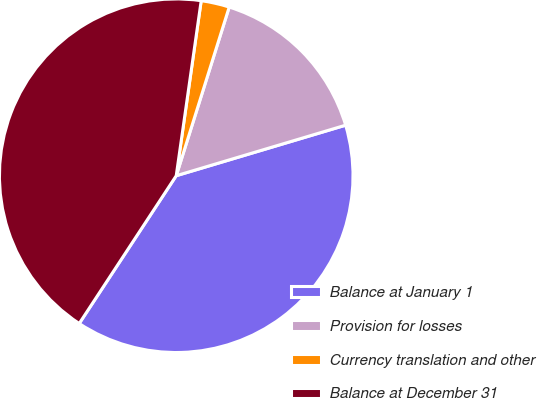Convert chart to OTSL. <chart><loc_0><loc_0><loc_500><loc_500><pie_chart><fcel>Balance at January 1<fcel>Provision for losses<fcel>Currency translation and other<fcel>Balance at December 31<nl><fcel>38.86%<fcel>15.54%<fcel>2.59%<fcel>43.01%<nl></chart> 